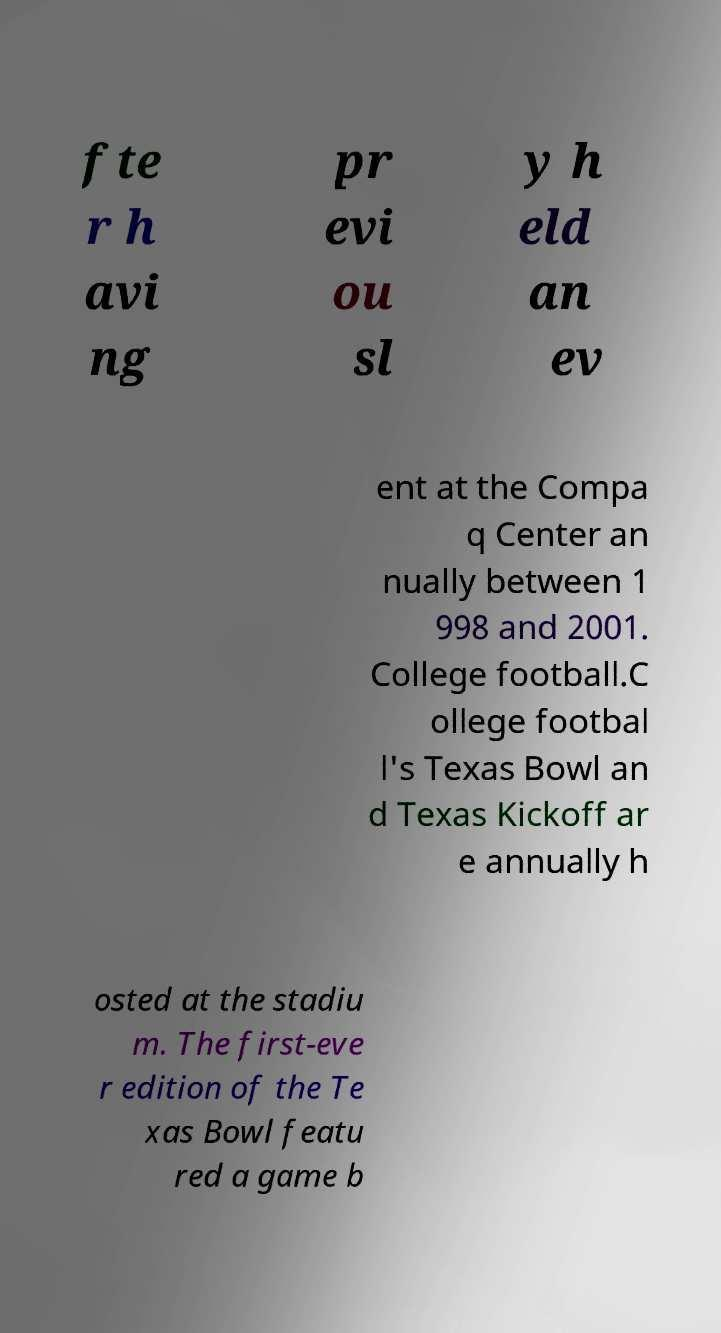Please identify and transcribe the text found in this image. fte r h avi ng pr evi ou sl y h eld an ev ent at the Compa q Center an nually between 1 998 and 2001. College football.C ollege footbal l's Texas Bowl an d Texas Kickoff ar e annually h osted at the stadiu m. The first-eve r edition of the Te xas Bowl featu red a game b 